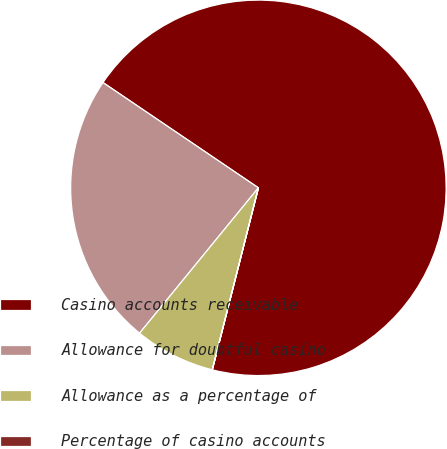<chart> <loc_0><loc_0><loc_500><loc_500><pie_chart><fcel>Casino accounts receivable<fcel>Allowance for doubtful casino<fcel>Allowance as a percentage of<fcel>Percentage of casino accounts<nl><fcel>69.47%<fcel>23.57%<fcel>6.95%<fcel>0.01%<nl></chart> 